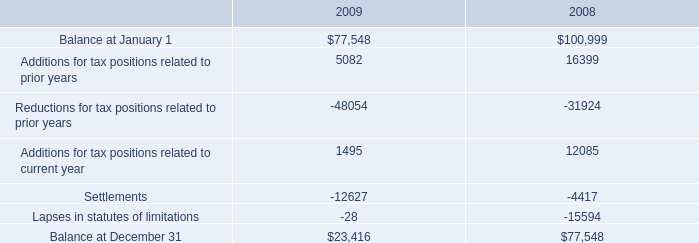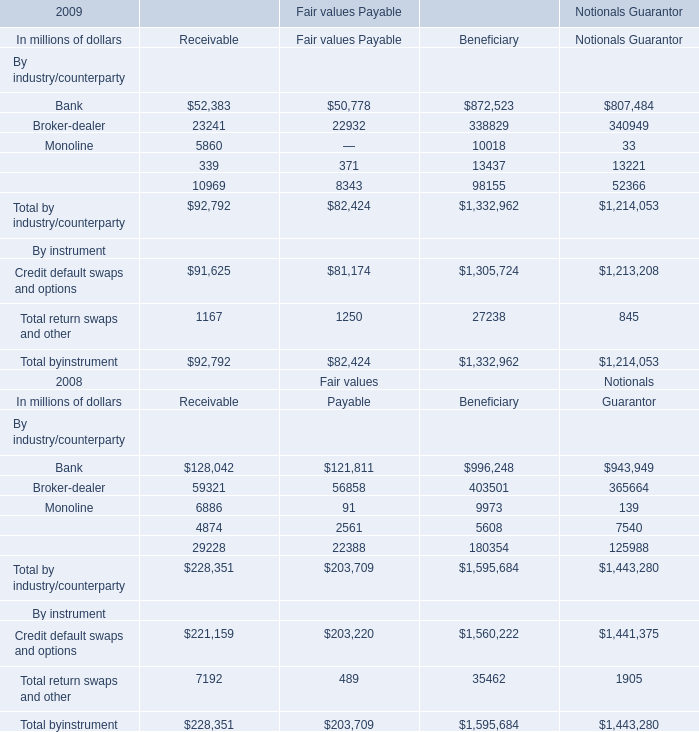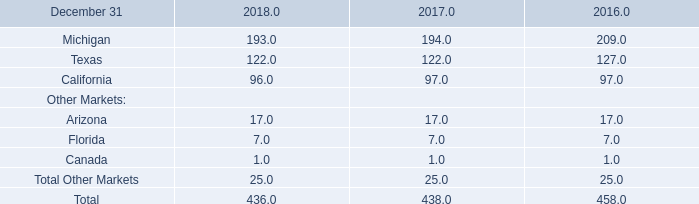What is the percentage of all By instrument that are positive to the total amount,in 2009 for Receivable ？ 
Computations: ((91625 + 1167) / 92792)
Answer: 1.0. What's the sum of all By instrument that are positive in 2009 for Receivable? (in million) 
Computations: (91625 + 1167)
Answer: 92792.0. 